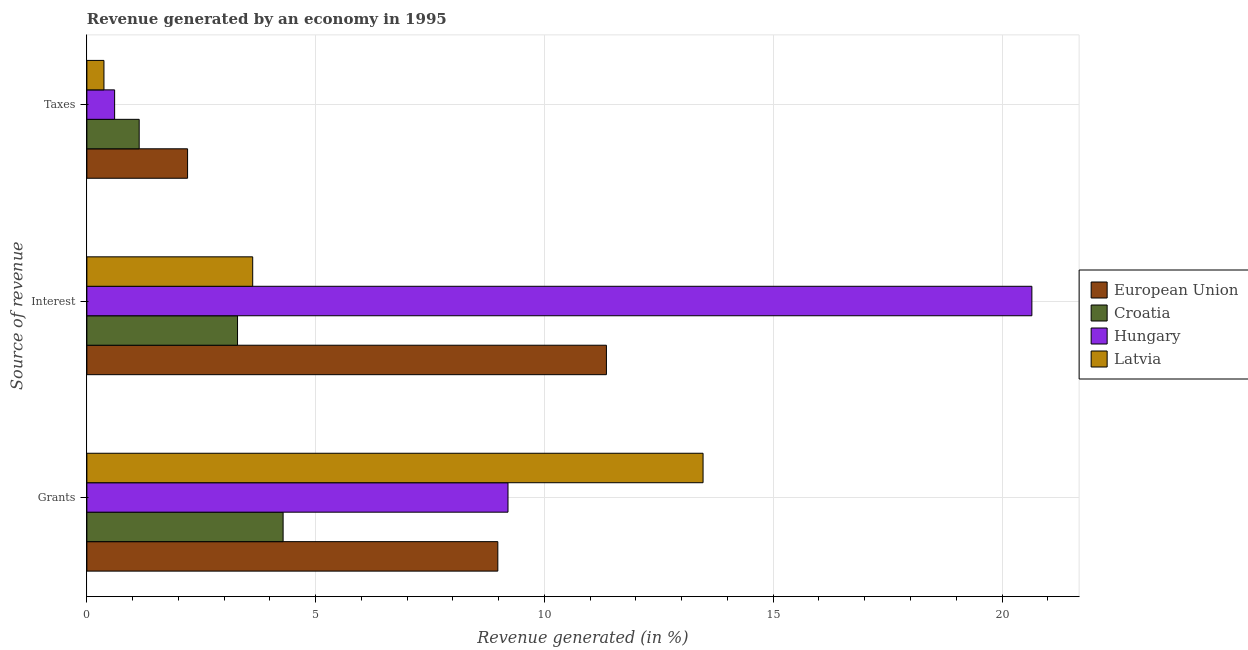How many different coloured bars are there?
Keep it short and to the point. 4. Are the number of bars per tick equal to the number of legend labels?
Your answer should be very brief. Yes. Are the number of bars on each tick of the Y-axis equal?
Your response must be concise. Yes. How many bars are there on the 1st tick from the top?
Keep it short and to the point. 4. How many bars are there on the 1st tick from the bottom?
Ensure brevity in your answer.  4. What is the label of the 3rd group of bars from the top?
Provide a succinct answer. Grants. What is the percentage of revenue generated by grants in European Union?
Your answer should be compact. 8.98. Across all countries, what is the maximum percentage of revenue generated by taxes?
Make the answer very short. 2.2. Across all countries, what is the minimum percentage of revenue generated by grants?
Your response must be concise. 4.29. In which country was the percentage of revenue generated by interest maximum?
Your response must be concise. Hungary. In which country was the percentage of revenue generated by interest minimum?
Give a very brief answer. Croatia. What is the total percentage of revenue generated by grants in the graph?
Your response must be concise. 35.94. What is the difference between the percentage of revenue generated by grants in Latvia and that in Hungary?
Your answer should be compact. 4.26. What is the difference between the percentage of revenue generated by interest in Hungary and the percentage of revenue generated by grants in Latvia?
Provide a succinct answer. 7.19. What is the average percentage of revenue generated by grants per country?
Offer a very short reply. 8.98. What is the difference between the percentage of revenue generated by grants and percentage of revenue generated by taxes in European Union?
Make the answer very short. 6.78. What is the ratio of the percentage of revenue generated by grants in Croatia to that in Latvia?
Offer a very short reply. 0.32. What is the difference between the highest and the second highest percentage of revenue generated by grants?
Give a very brief answer. 4.26. What is the difference between the highest and the lowest percentage of revenue generated by taxes?
Provide a short and direct response. 1.83. In how many countries, is the percentage of revenue generated by taxes greater than the average percentage of revenue generated by taxes taken over all countries?
Provide a succinct answer. 2. What does the 3rd bar from the top in Interest represents?
Your response must be concise. Croatia. How many countries are there in the graph?
Your answer should be compact. 4. Are the values on the major ticks of X-axis written in scientific E-notation?
Keep it short and to the point. No. Does the graph contain any zero values?
Provide a short and direct response. No. Does the graph contain grids?
Provide a succinct answer. Yes. Where does the legend appear in the graph?
Keep it short and to the point. Center right. What is the title of the graph?
Provide a succinct answer. Revenue generated by an economy in 1995. What is the label or title of the X-axis?
Give a very brief answer. Revenue generated (in %). What is the label or title of the Y-axis?
Offer a terse response. Source of revenue. What is the Revenue generated (in %) in European Union in Grants?
Your answer should be very brief. 8.98. What is the Revenue generated (in %) of Croatia in Grants?
Offer a terse response. 4.29. What is the Revenue generated (in %) of Hungary in Grants?
Offer a terse response. 9.2. What is the Revenue generated (in %) in Latvia in Grants?
Keep it short and to the point. 13.47. What is the Revenue generated (in %) of European Union in Interest?
Provide a short and direct response. 11.35. What is the Revenue generated (in %) in Croatia in Interest?
Provide a short and direct response. 3.29. What is the Revenue generated (in %) of Hungary in Interest?
Your response must be concise. 20.65. What is the Revenue generated (in %) of Latvia in Interest?
Your answer should be compact. 3.62. What is the Revenue generated (in %) in European Union in Taxes?
Provide a short and direct response. 2.2. What is the Revenue generated (in %) of Croatia in Taxes?
Give a very brief answer. 1.14. What is the Revenue generated (in %) in Hungary in Taxes?
Make the answer very short. 0.61. What is the Revenue generated (in %) of Latvia in Taxes?
Make the answer very short. 0.37. Across all Source of revenue, what is the maximum Revenue generated (in %) in European Union?
Keep it short and to the point. 11.35. Across all Source of revenue, what is the maximum Revenue generated (in %) in Croatia?
Make the answer very short. 4.29. Across all Source of revenue, what is the maximum Revenue generated (in %) of Hungary?
Offer a terse response. 20.65. Across all Source of revenue, what is the maximum Revenue generated (in %) of Latvia?
Provide a succinct answer. 13.47. Across all Source of revenue, what is the minimum Revenue generated (in %) of European Union?
Your answer should be compact. 2.2. Across all Source of revenue, what is the minimum Revenue generated (in %) in Croatia?
Your response must be concise. 1.14. Across all Source of revenue, what is the minimum Revenue generated (in %) in Hungary?
Provide a short and direct response. 0.61. Across all Source of revenue, what is the minimum Revenue generated (in %) of Latvia?
Give a very brief answer. 0.37. What is the total Revenue generated (in %) of European Union in the graph?
Your response must be concise. 22.54. What is the total Revenue generated (in %) of Croatia in the graph?
Your answer should be very brief. 8.72. What is the total Revenue generated (in %) in Hungary in the graph?
Your response must be concise. 30.46. What is the total Revenue generated (in %) in Latvia in the graph?
Offer a terse response. 17.46. What is the difference between the Revenue generated (in %) in European Union in Grants and that in Interest?
Your response must be concise. -2.37. What is the difference between the Revenue generated (in %) in Croatia in Grants and that in Interest?
Offer a terse response. 1. What is the difference between the Revenue generated (in %) of Hungary in Grants and that in Interest?
Offer a terse response. -11.45. What is the difference between the Revenue generated (in %) in Latvia in Grants and that in Interest?
Make the answer very short. 9.84. What is the difference between the Revenue generated (in %) of European Union in Grants and that in Taxes?
Provide a succinct answer. 6.78. What is the difference between the Revenue generated (in %) in Croatia in Grants and that in Taxes?
Provide a succinct answer. 3.15. What is the difference between the Revenue generated (in %) of Hungary in Grants and that in Taxes?
Ensure brevity in your answer.  8.6. What is the difference between the Revenue generated (in %) in Latvia in Grants and that in Taxes?
Provide a short and direct response. 13.09. What is the difference between the Revenue generated (in %) of European Union in Interest and that in Taxes?
Provide a succinct answer. 9.15. What is the difference between the Revenue generated (in %) in Croatia in Interest and that in Taxes?
Your response must be concise. 2.15. What is the difference between the Revenue generated (in %) in Hungary in Interest and that in Taxes?
Offer a very short reply. 20.05. What is the difference between the Revenue generated (in %) of Latvia in Interest and that in Taxes?
Offer a very short reply. 3.25. What is the difference between the Revenue generated (in %) of European Union in Grants and the Revenue generated (in %) of Croatia in Interest?
Provide a short and direct response. 5.69. What is the difference between the Revenue generated (in %) in European Union in Grants and the Revenue generated (in %) in Hungary in Interest?
Provide a succinct answer. -11.67. What is the difference between the Revenue generated (in %) of European Union in Grants and the Revenue generated (in %) of Latvia in Interest?
Give a very brief answer. 5.36. What is the difference between the Revenue generated (in %) of Croatia in Grants and the Revenue generated (in %) of Hungary in Interest?
Ensure brevity in your answer.  -16.36. What is the difference between the Revenue generated (in %) of Croatia in Grants and the Revenue generated (in %) of Latvia in Interest?
Your response must be concise. 0.66. What is the difference between the Revenue generated (in %) of Hungary in Grants and the Revenue generated (in %) of Latvia in Interest?
Provide a succinct answer. 5.58. What is the difference between the Revenue generated (in %) of European Union in Grants and the Revenue generated (in %) of Croatia in Taxes?
Your response must be concise. 7.84. What is the difference between the Revenue generated (in %) of European Union in Grants and the Revenue generated (in %) of Hungary in Taxes?
Give a very brief answer. 8.37. What is the difference between the Revenue generated (in %) in European Union in Grants and the Revenue generated (in %) in Latvia in Taxes?
Offer a very short reply. 8.61. What is the difference between the Revenue generated (in %) of Croatia in Grants and the Revenue generated (in %) of Hungary in Taxes?
Give a very brief answer. 3.68. What is the difference between the Revenue generated (in %) in Croatia in Grants and the Revenue generated (in %) in Latvia in Taxes?
Provide a short and direct response. 3.92. What is the difference between the Revenue generated (in %) in Hungary in Grants and the Revenue generated (in %) in Latvia in Taxes?
Offer a very short reply. 8.83. What is the difference between the Revenue generated (in %) of European Union in Interest and the Revenue generated (in %) of Croatia in Taxes?
Provide a short and direct response. 10.21. What is the difference between the Revenue generated (in %) of European Union in Interest and the Revenue generated (in %) of Hungary in Taxes?
Provide a short and direct response. 10.75. What is the difference between the Revenue generated (in %) in European Union in Interest and the Revenue generated (in %) in Latvia in Taxes?
Give a very brief answer. 10.98. What is the difference between the Revenue generated (in %) of Croatia in Interest and the Revenue generated (in %) of Hungary in Taxes?
Your answer should be compact. 2.69. What is the difference between the Revenue generated (in %) in Croatia in Interest and the Revenue generated (in %) in Latvia in Taxes?
Your answer should be very brief. 2.92. What is the difference between the Revenue generated (in %) in Hungary in Interest and the Revenue generated (in %) in Latvia in Taxes?
Offer a terse response. 20.28. What is the average Revenue generated (in %) in European Union per Source of revenue?
Make the answer very short. 7.51. What is the average Revenue generated (in %) in Croatia per Source of revenue?
Ensure brevity in your answer.  2.91. What is the average Revenue generated (in %) of Hungary per Source of revenue?
Offer a very short reply. 10.15. What is the average Revenue generated (in %) of Latvia per Source of revenue?
Offer a terse response. 5.82. What is the difference between the Revenue generated (in %) in European Union and Revenue generated (in %) in Croatia in Grants?
Provide a succinct answer. 4.69. What is the difference between the Revenue generated (in %) in European Union and Revenue generated (in %) in Hungary in Grants?
Keep it short and to the point. -0.22. What is the difference between the Revenue generated (in %) of European Union and Revenue generated (in %) of Latvia in Grants?
Keep it short and to the point. -4.49. What is the difference between the Revenue generated (in %) in Croatia and Revenue generated (in %) in Hungary in Grants?
Your response must be concise. -4.91. What is the difference between the Revenue generated (in %) of Croatia and Revenue generated (in %) of Latvia in Grants?
Offer a very short reply. -9.18. What is the difference between the Revenue generated (in %) of Hungary and Revenue generated (in %) of Latvia in Grants?
Offer a very short reply. -4.26. What is the difference between the Revenue generated (in %) in European Union and Revenue generated (in %) in Croatia in Interest?
Your answer should be compact. 8.06. What is the difference between the Revenue generated (in %) in European Union and Revenue generated (in %) in Hungary in Interest?
Your response must be concise. -9.3. What is the difference between the Revenue generated (in %) in European Union and Revenue generated (in %) in Latvia in Interest?
Provide a short and direct response. 7.73. What is the difference between the Revenue generated (in %) in Croatia and Revenue generated (in %) in Hungary in Interest?
Provide a short and direct response. -17.36. What is the difference between the Revenue generated (in %) in Croatia and Revenue generated (in %) in Latvia in Interest?
Offer a very short reply. -0.33. What is the difference between the Revenue generated (in %) of Hungary and Revenue generated (in %) of Latvia in Interest?
Provide a short and direct response. 17.03. What is the difference between the Revenue generated (in %) of European Union and Revenue generated (in %) of Croatia in Taxes?
Make the answer very short. 1.06. What is the difference between the Revenue generated (in %) of European Union and Revenue generated (in %) of Hungary in Taxes?
Keep it short and to the point. 1.59. What is the difference between the Revenue generated (in %) of European Union and Revenue generated (in %) of Latvia in Taxes?
Your answer should be very brief. 1.83. What is the difference between the Revenue generated (in %) in Croatia and Revenue generated (in %) in Hungary in Taxes?
Offer a very short reply. 0.54. What is the difference between the Revenue generated (in %) in Croatia and Revenue generated (in %) in Latvia in Taxes?
Your response must be concise. 0.77. What is the difference between the Revenue generated (in %) of Hungary and Revenue generated (in %) of Latvia in Taxes?
Provide a succinct answer. 0.23. What is the ratio of the Revenue generated (in %) of European Union in Grants to that in Interest?
Provide a short and direct response. 0.79. What is the ratio of the Revenue generated (in %) of Croatia in Grants to that in Interest?
Ensure brevity in your answer.  1.3. What is the ratio of the Revenue generated (in %) in Hungary in Grants to that in Interest?
Offer a terse response. 0.45. What is the ratio of the Revenue generated (in %) of Latvia in Grants to that in Interest?
Give a very brief answer. 3.72. What is the ratio of the Revenue generated (in %) of European Union in Grants to that in Taxes?
Offer a terse response. 4.08. What is the ratio of the Revenue generated (in %) in Croatia in Grants to that in Taxes?
Make the answer very short. 3.75. What is the ratio of the Revenue generated (in %) in Hungary in Grants to that in Taxes?
Offer a very short reply. 15.18. What is the ratio of the Revenue generated (in %) in Latvia in Grants to that in Taxes?
Provide a short and direct response. 36.08. What is the ratio of the Revenue generated (in %) of European Union in Interest to that in Taxes?
Keep it short and to the point. 5.16. What is the ratio of the Revenue generated (in %) of Croatia in Interest to that in Taxes?
Offer a very short reply. 2.88. What is the ratio of the Revenue generated (in %) in Hungary in Interest to that in Taxes?
Your answer should be very brief. 34.06. What is the ratio of the Revenue generated (in %) in Latvia in Interest to that in Taxes?
Keep it short and to the point. 9.71. What is the difference between the highest and the second highest Revenue generated (in %) of European Union?
Provide a short and direct response. 2.37. What is the difference between the highest and the second highest Revenue generated (in %) in Hungary?
Offer a terse response. 11.45. What is the difference between the highest and the second highest Revenue generated (in %) of Latvia?
Keep it short and to the point. 9.84. What is the difference between the highest and the lowest Revenue generated (in %) of European Union?
Keep it short and to the point. 9.15. What is the difference between the highest and the lowest Revenue generated (in %) in Croatia?
Provide a succinct answer. 3.15. What is the difference between the highest and the lowest Revenue generated (in %) in Hungary?
Your answer should be very brief. 20.05. What is the difference between the highest and the lowest Revenue generated (in %) of Latvia?
Make the answer very short. 13.09. 